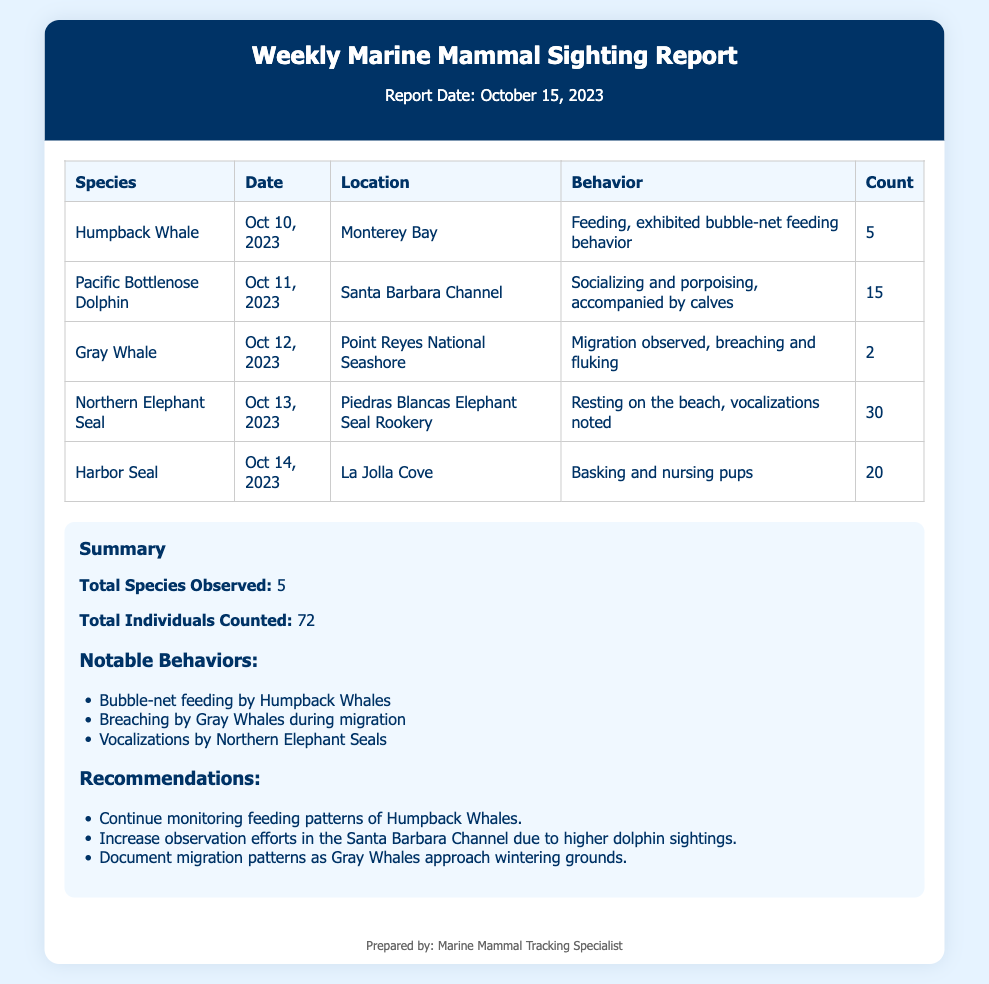What species were observed on October 10, 2023? The document lists the species observed along with their respective dates. On October 10, 2023, the Humpback Whale was observed.
Answer: Humpback Whale How many Pacific Bottlenose Dolphins were counted? The count of Pacific Bottlenose Dolphins is provided in the table under the Count column.
Answer: 15 What behavior was noted for Gray Whales? The behaviors exhibited by each species are detailed in the Behavior column. Gray Whales were observed breaching and fluking during migration.
Answer: Migration observed, breaching and fluking Which location had the highest number of Northern Elephant Seals? The document includes a count of Northern Elephant Seals from the table. The highest count occurred at Piedras Blancas Elephant Seal Rookery.
Answer: Piedras Blancas Elephant Seal Rookery What is the total number of individuals counted? The total individuals count is given as a summary in the document. It is the sum of all counts listed.
Answer: 72 Identify one notable behavior of the Humpback Whale. The notable behaviors are mentioned in the summary section under Notable Behaviors. Humpback Whales exhibited bubble-net feeding behavior.
Answer: Bubble-net feeding How many species were documented in total? The total species observed is mentioned in the summary section of the document.
Answer: 5 What recommendation is made regarding the Santa Barbara Channel? The document provides recommendations based on observations. The recommendation suggests increasing observation efforts in the Santa Barbara Channel.
Answer: Increase observation efforts in the Santa Barbara Channel On what date was the report prepared? The report date is stated at the top of the document under the header.
Answer: October 15, 2023 